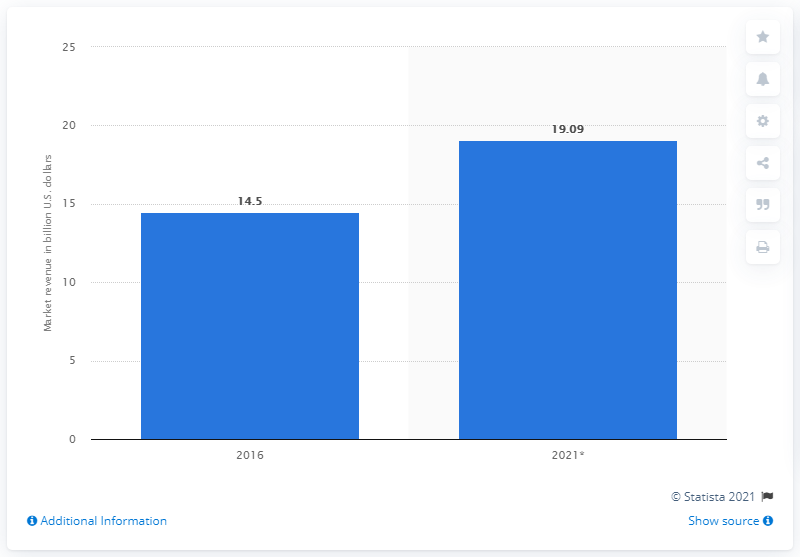List a handful of essential elements in this visual. In 2016, the global photo printing and merchandising market was worth approximately 14.5... 